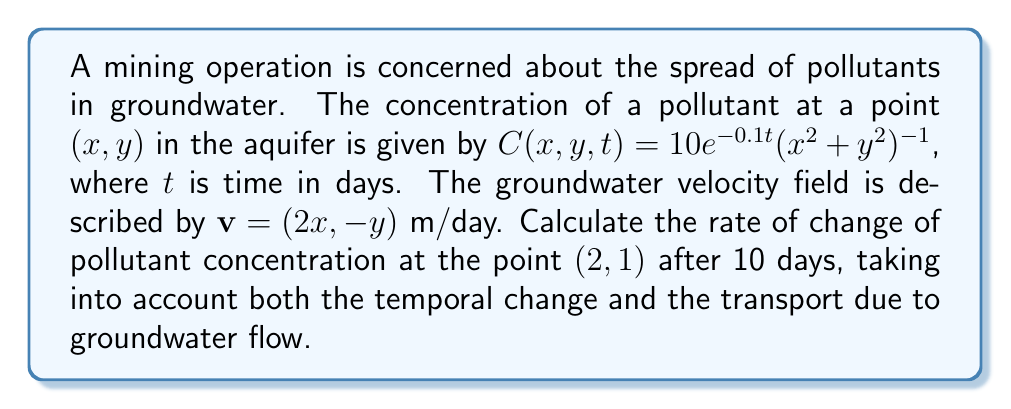Could you help me with this problem? To solve this problem, we need to use the material derivative, which combines the partial time derivative and the spatial derivatives influenced by the velocity field. The material derivative is given by:

$$\frac{DC}{Dt} = \frac{\partial C}{\partial t} + \mathbf{v} \cdot \nabla C$$

Let's break this down step-by-step:

1) First, calculate $\frac{\partial C}{\partial t}$:
   $$\frac{\partial C}{\partial t} = -10 \cdot 0.1e^{-0.1t}(x^2 + y^2)^{-1} = -e^{-0.1t}(x^2 + y^2)^{-1}$$

2) Next, calculate $\nabla C$:
   $$\nabla C = \left(\frac{\partial C}{\partial x}, \frac{\partial C}{\partial y}\right) = \left(-20xe^{-0.1t}(x^2+y^2)^{-2}, -20ye^{-0.1t}(x^2+y^2)^{-2}\right)$$

3) Calculate $\mathbf{v} \cdot \nabla C$:
   $$\mathbf{v} \cdot \nabla C = (2x, -y) \cdot \left(-20xe^{-0.1t}(x^2+y^2)^{-2}, -20ye^{-0.1t}(x^2+y^2)^{-2}\right)$$
   $$= -40x^2e^{-0.1t}(x^2+y^2)^{-2} + 20y^2e^{-0.1t}(x^2+y^2)^{-2}$$
   $$= -20e^{-0.1t}(x^2+y^2)^{-2}(2x^2 - y^2)$$

4) Combine the results in the material derivative:
   $$\frac{DC}{Dt} = -e^{-0.1t}(x^2 + y^2)^{-1} - 20e^{-0.1t}(x^2+y^2)^{-2}(2x^2 - y^2)$$

5) Evaluate at the point $(2,1)$ after 10 days:
   $$\frac{DC}{Dt}|_{(2,1,10)} = -e^{-1}(5)^{-1} - 20e^{-1}(5)^{-2}(8 - 1)$$
   $$= -0.0736 - 0.2062 = -0.2798$$

The negative value indicates that the concentration is decreasing at this point and time.
Answer: $-0.2798$ concentration units per day 